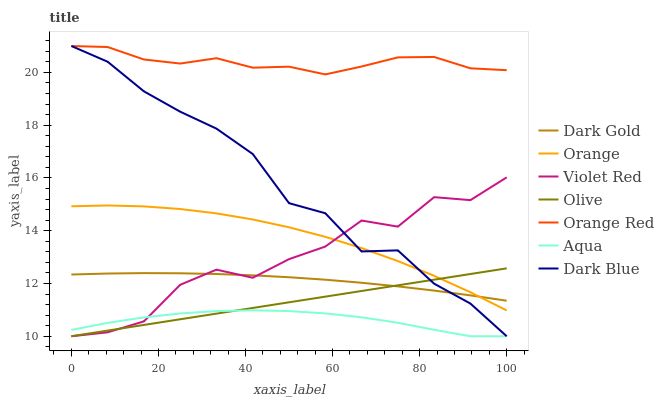Does Aqua have the minimum area under the curve?
Answer yes or no. Yes. Does Orange Red have the maximum area under the curve?
Answer yes or no. Yes. Does Dark Gold have the minimum area under the curve?
Answer yes or no. No. Does Dark Gold have the maximum area under the curve?
Answer yes or no. No. Is Olive the smoothest?
Answer yes or no. Yes. Is Violet Red the roughest?
Answer yes or no. Yes. Is Dark Gold the smoothest?
Answer yes or no. No. Is Dark Gold the roughest?
Answer yes or no. No. Does Violet Red have the lowest value?
Answer yes or no. Yes. Does Dark Gold have the lowest value?
Answer yes or no. No. Does Orange Red have the highest value?
Answer yes or no. Yes. Does Dark Gold have the highest value?
Answer yes or no. No. Is Orange less than Orange Red?
Answer yes or no. Yes. Is Orange Red greater than Orange?
Answer yes or no. Yes. Does Violet Red intersect Orange?
Answer yes or no. Yes. Is Violet Red less than Orange?
Answer yes or no. No. Is Violet Red greater than Orange?
Answer yes or no. No. Does Orange intersect Orange Red?
Answer yes or no. No. 